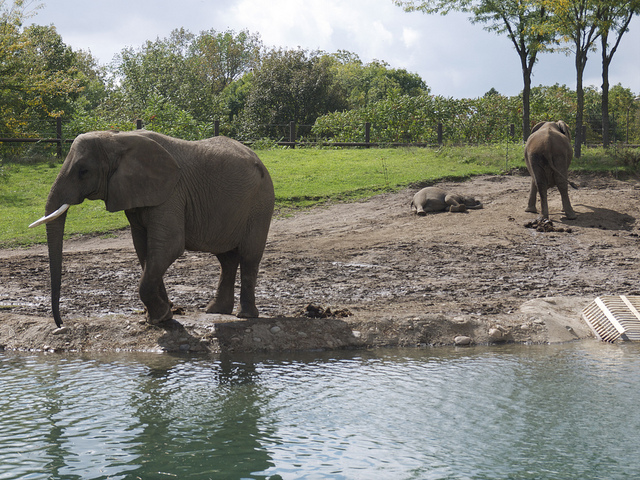Describe the weather conditions in this image. The weather in the image appears to be quite pleasant. The sky is partly cloudy, allowing for intervals of sunshine, and the foliage around the enclosure suggests it could be a warm day, ideal for the elephants to enjoy their time outdoors. 